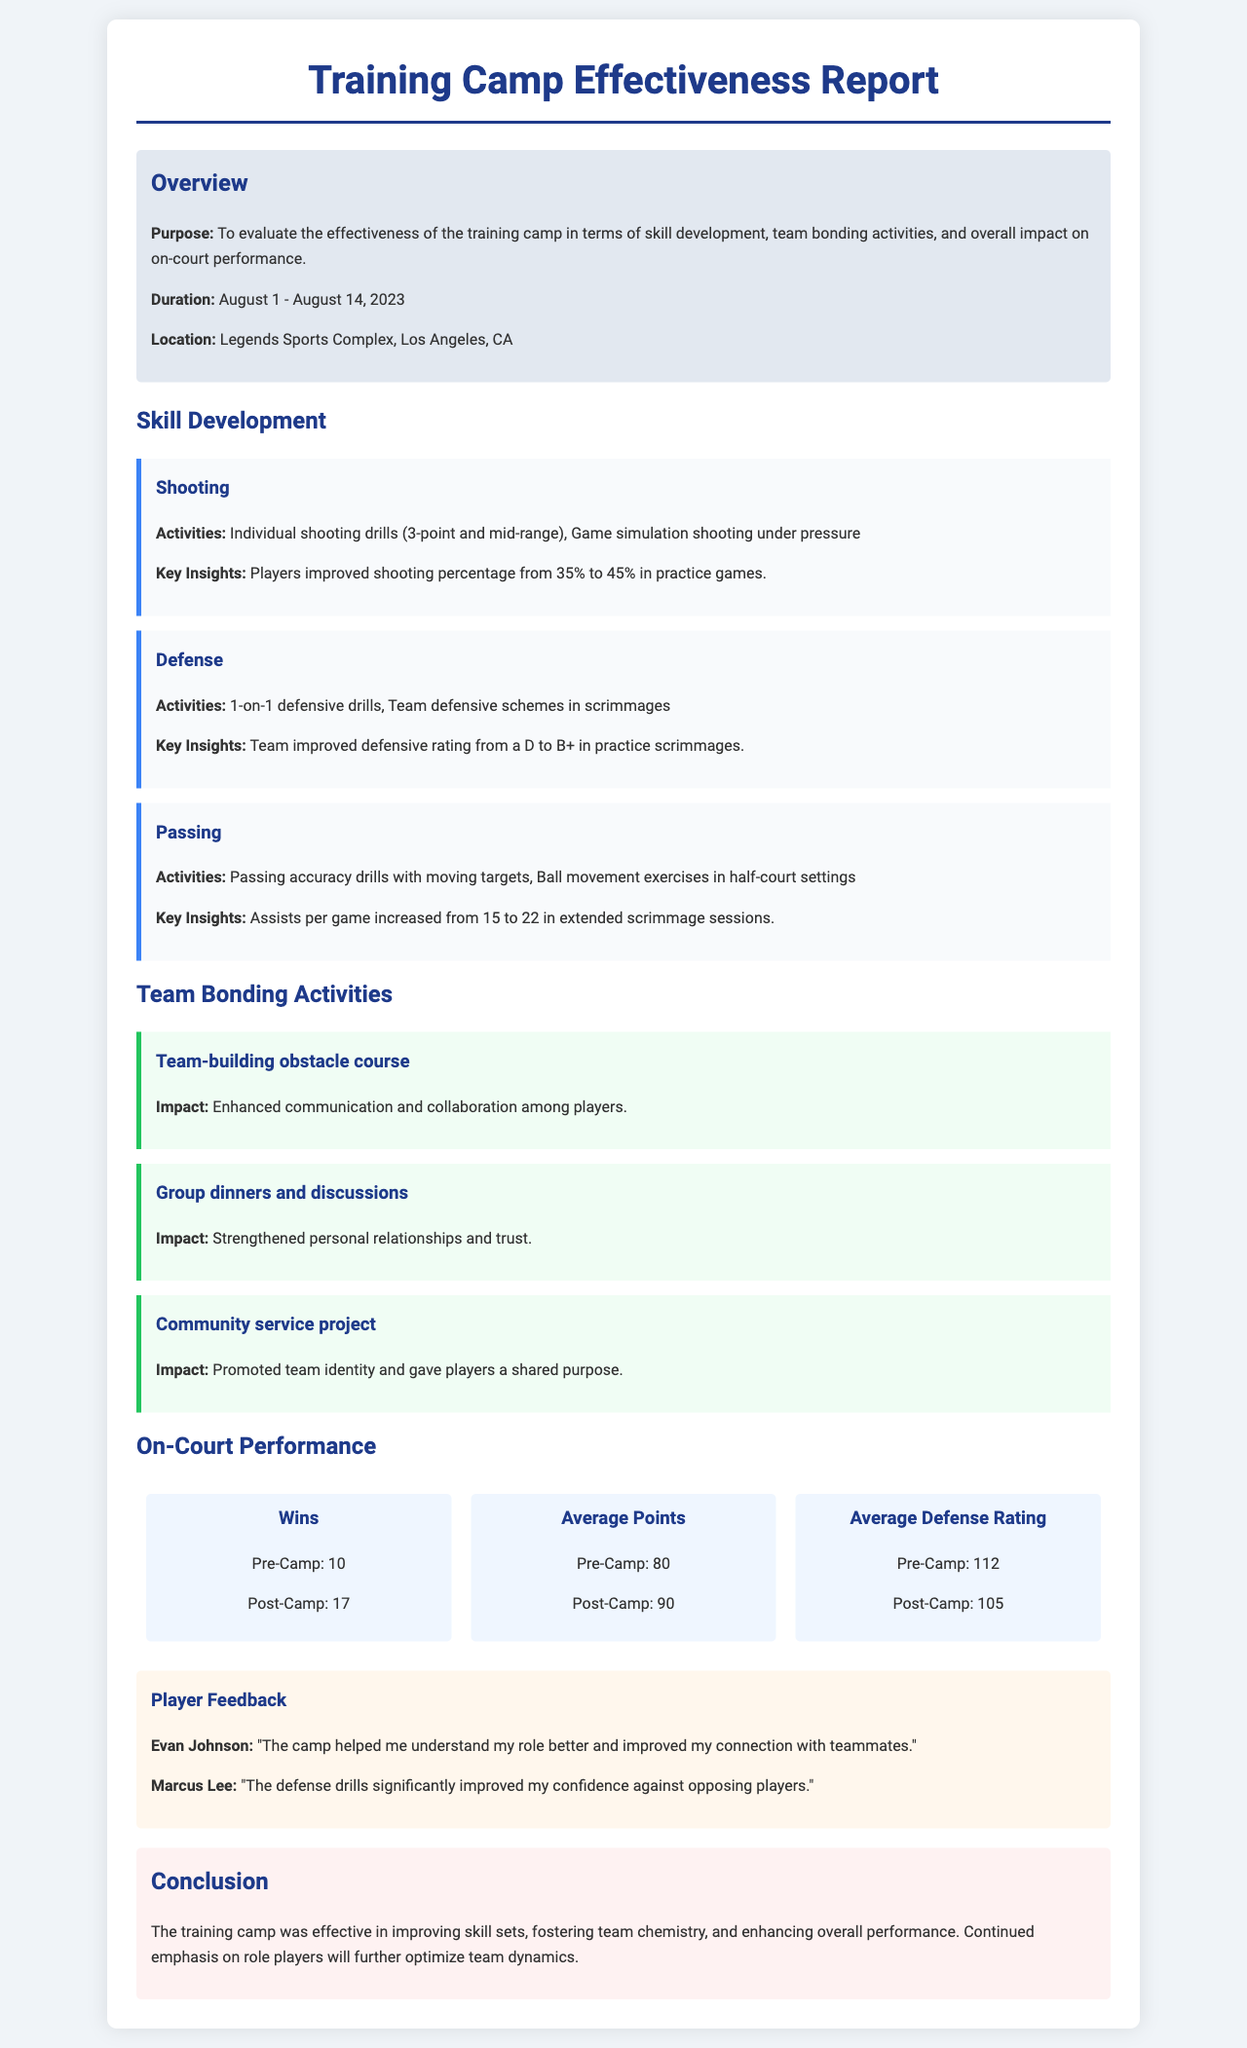What was the duration of the training camp? The document states the training camp lasted from August 1 to August 14, 2023.
Answer: August 1 - August 14, 2023 What is the location of the training camp? The report mentions that the training camp took place at Legends Sports Complex in Los Angeles, CA.
Answer: Legends Sports Complex, Los Angeles, CA How much did the shooting percentage improve? The key insight for shooting indicates an improvement from 35% to 45%.
Answer: 10% What was the team's defensive rating improvement? The defensive rating improved from a D to a B+, indicating a significant upgrade in performance.
Answer: D to B+ What activities were included in the team bonding section? The report lists activities such as a team-building obstacle course, group dinners, and a community service project.
Answer: Team-building obstacle course, group dinners, and community service project How many wins were there post-camp? The metrics section shows that the team had 17 wins after the camp.
Answer: 17 What feedback did Evan Johnson provide about the camp? Evan Johnson stated that the camp helped him understand his role better and improved his connection with teammates.
Answer: "The camp helped me understand my role better and improved my connection with teammates." What is the conclusion drawn from the training camp's effectiveness? The conclusion emphasizes the camp's success in improving skills and team chemistry, and notes the importance of focusing on role players.
Answer: The training camp was effective in improving skill sets, fostering team chemistry, and enhancing overall performance 